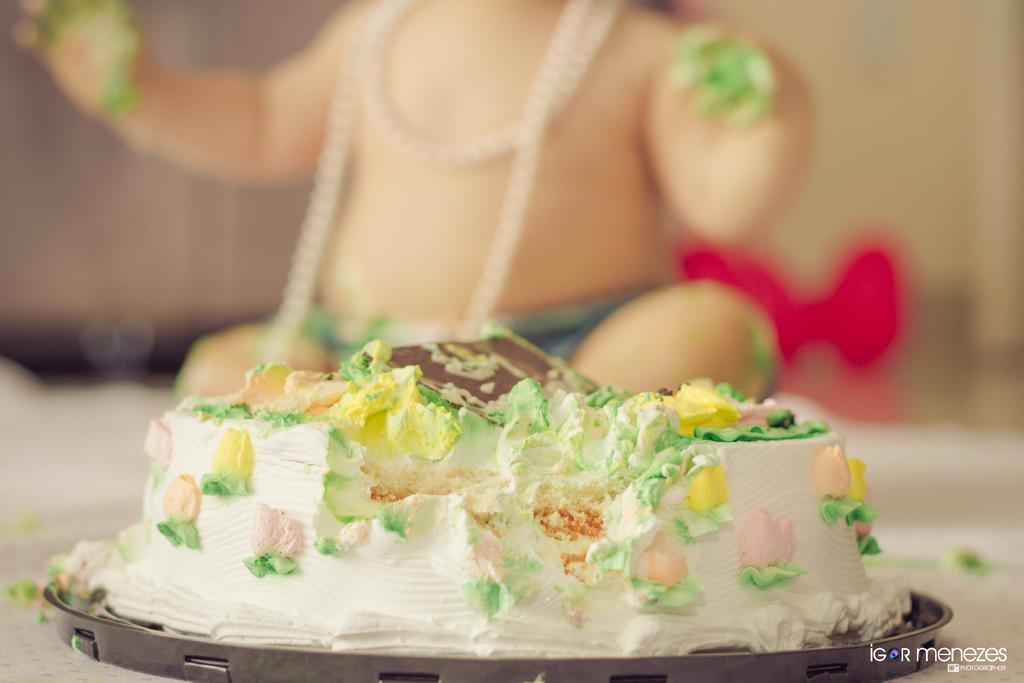What is the main subject in the center of the image? There is a cake in the center of the image. Can you describe anything else visible in the image? There is a child in the background of the image. How many bridges can be seen crossing the river in the image? There are no bridges visible in the image; it features a cake and a child. What type of mouth is the representative of the cake in the image? There is no representative of the cake in the image, and therefore no mouth can be observed. 